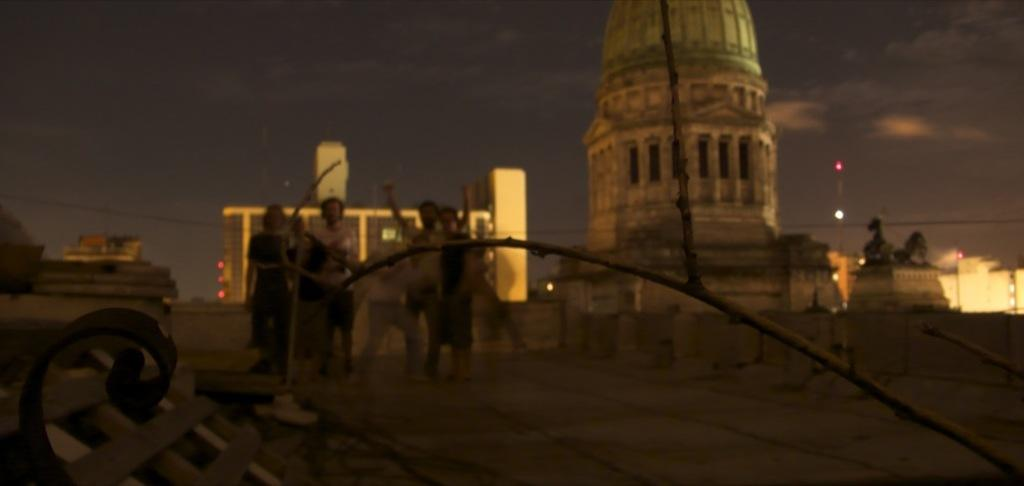What is happening in the image? There is a group of people standing in the image. What can be seen in the background of the image? There are buildings in the background of the image. What colors are the buildings? The buildings are in white and cream colors. What else is visible in the image? There are lights visible in the image. What is the condition of the sky in the image? The sky is visible in the image. What type of soda is being served in the field in the image? There is no soda or field present in the image; it features a group of people standing with buildings in the background. What type of rake is being used by the person in the image? There is no rake or person using a rake present in the image. 